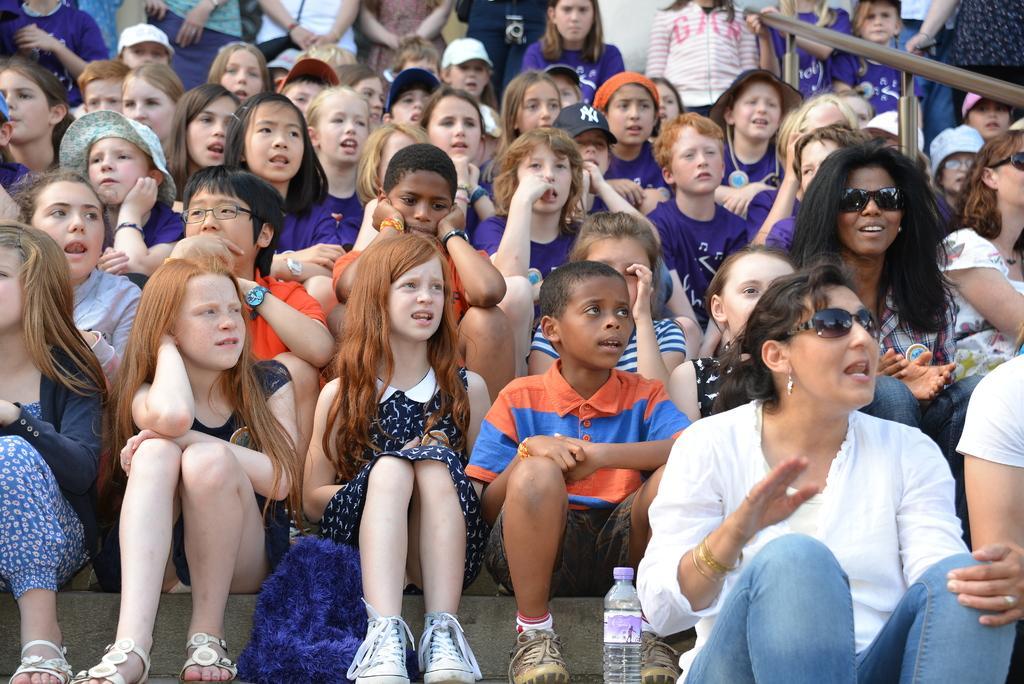Please provide a concise description of this image. This image is taken outdoors. In the background a few are standing and there is a railing. In the middle of the image many people are sitting on the stairs. There is a scarf and there is a water bottle. A few have worn caps and hats. 